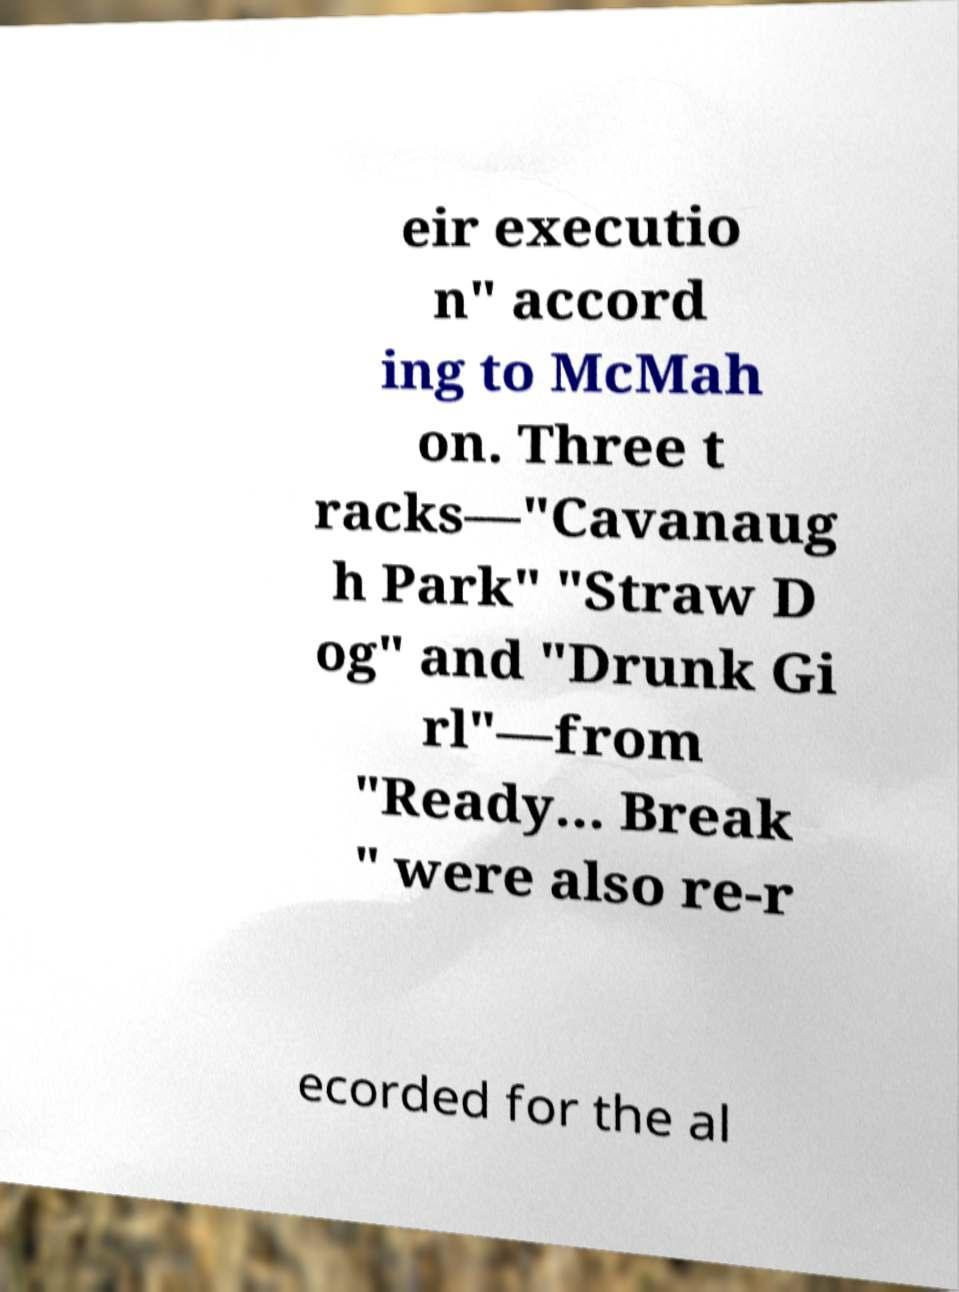I need the written content from this picture converted into text. Can you do that? eir executio n" accord ing to McMah on. Three t racks—"Cavanaug h Park" "Straw D og" and "Drunk Gi rl"—from "Ready... Break " were also re-r ecorded for the al 